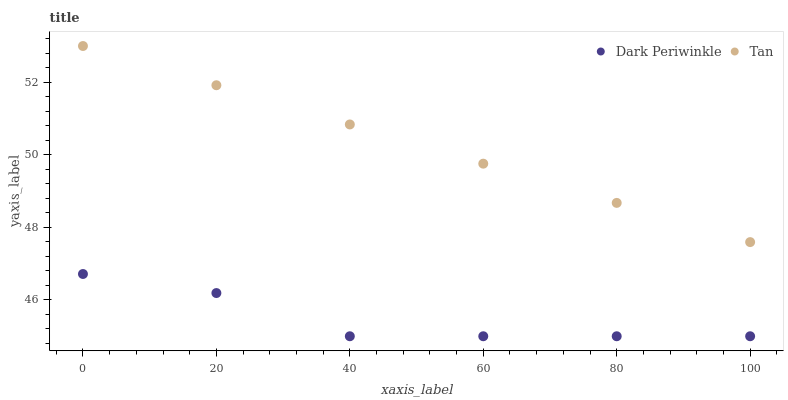Does Dark Periwinkle have the minimum area under the curve?
Answer yes or no. Yes. Does Tan have the maximum area under the curve?
Answer yes or no. Yes. Does Dark Periwinkle have the maximum area under the curve?
Answer yes or no. No. Is Tan the smoothest?
Answer yes or no. Yes. Is Dark Periwinkle the roughest?
Answer yes or no. Yes. Is Dark Periwinkle the smoothest?
Answer yes or no. No. Does Dark Periwinkle have the lowest value?
Answer yes or no. Yes. Does Tan have the highest value?
Answer yes or no. Yes. Does Dark Periwinkle have the highest value?
Answer yes or no. No. Is Dark Periwinkle less than Tan?
Answer yes or no. Yes. Is Tan greater than Dark Periwinkle?
Answer yes or no. Yes. Does Dark Periwinkle intersect Tan?
Answer yes or no. No. 